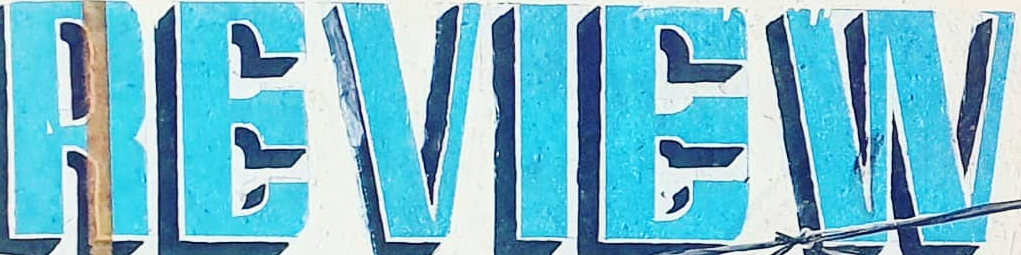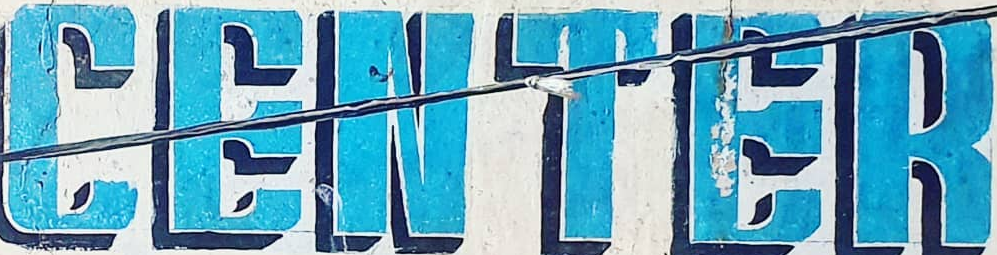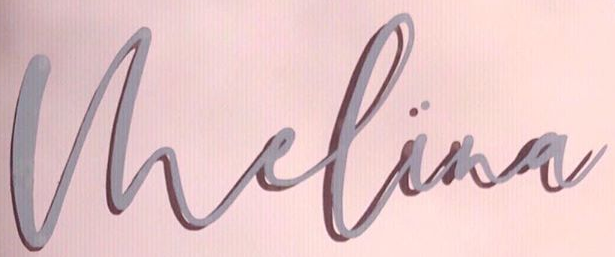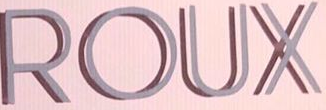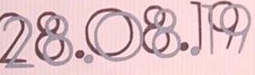What words are shown in these images in order, separated by a semicolon? REVIEW; CENTER; Vhelina; ROUX; 28.08.19 